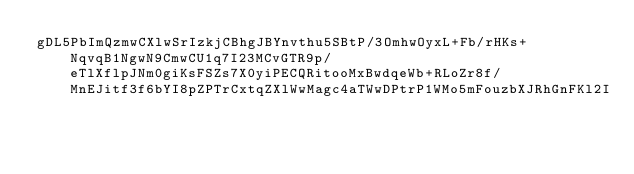Convert code to text. <code><loc_0><loc_0><loc_500><loc_500><_SML_>gDL5PbImQzmwCXlwSrIzkjCBhgJBYnvthu5SBtP/3OmhwOyxL+Fb/rHKs+NqvqB1NgwN9CmwCU1q7I23MCvGTR9p/eTlXflpJNm0giKsFSZs7X0yiPECQRitooMxBwdqeWb+RLoZr8f/MnEJitf3f6bYI8pZPTrCxtqZXlWwMagc4aTWwDPtrP1WMo5mFouzbXJRhGnFKl2I</code> 